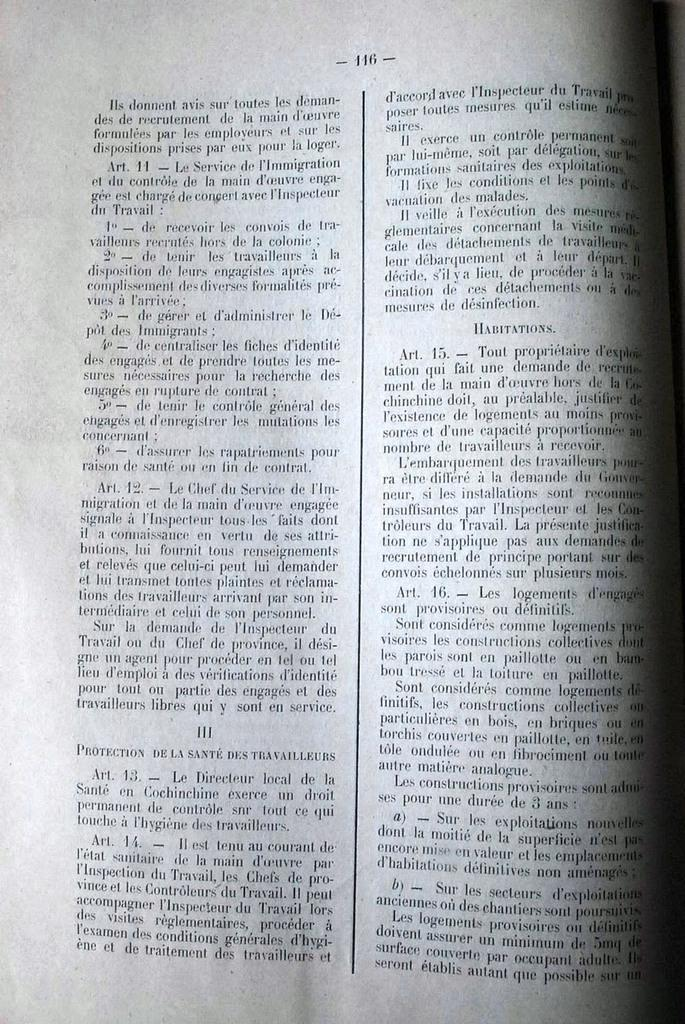What type of document is shown in the image? The image is a page of a book. What can be found on the page? There is text on the page. How many toads are visible on the page of the book in the image? There are no toads present on the page of the book in the image. What is the income of the author of the book in the image? The income of the author cannot be determined from the image, as it only shows a page of the book with text. 